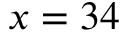<formula> <loc_0><loc_0><loc_500><loc_500>x = 3 4</formula> 